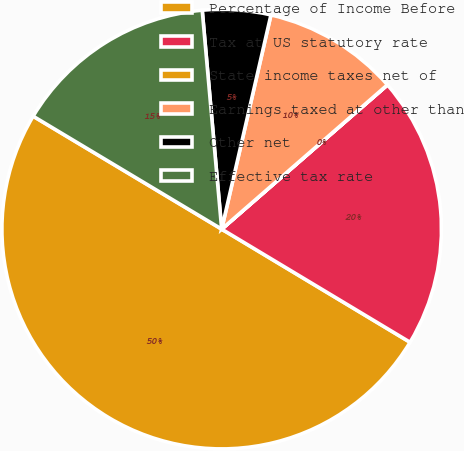Convert chart. <chart><loc_0><loc_0><loc_500><loc_500><pie_chart><fcel>Percentage of Income Before<fcel>Tax at US statutory rate<fcel>State income taxes net of<fcel>Earnings taxed at other than<fcel>Other net<fcel>Effective tax rate<nl><fcel>49.98%<fcel>20.0%<fcel>0.01%<fcel>10.0%<fcel>5.01%<fcel>15.0%<nl></chart> 